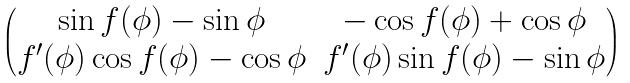<formula> <loc_0><loc_0><loc_500><loc_500>\begin{pmatrix} \sin f ( \phi ) - \sin \phi & - \cos f ( \phi ) + \cos \phi \\ f ^ { \prime } ( \phi ) \cos f ( \phi ) - \cos \phi & f ^ { \prime } ( \phi ) \sin f ( \phi ) - \sin \phi \end{pmatrix}</formula> 